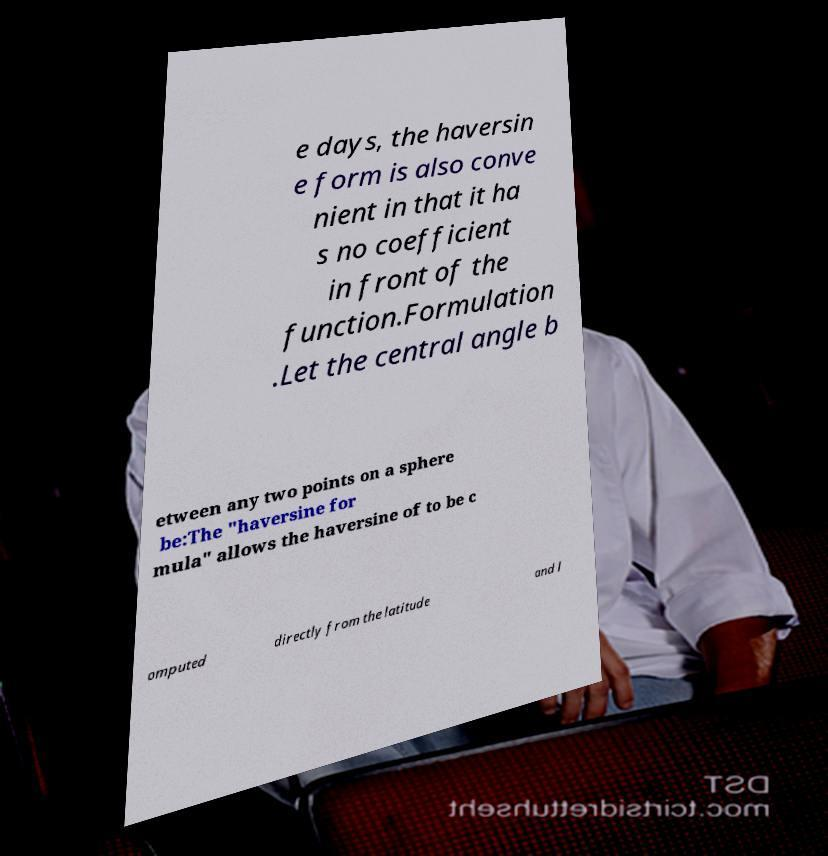There's text embedded in this image that I need extracted. Can you transcribe it verbatim? e days, the haversin e form is also conve nient in that it ha s no coefficient in front of the function.Formulation .Let the central angle b etween any two points on a sphere be:The "haversine for mula" allows the haversine of to be c omputed directly from the latitude and l 